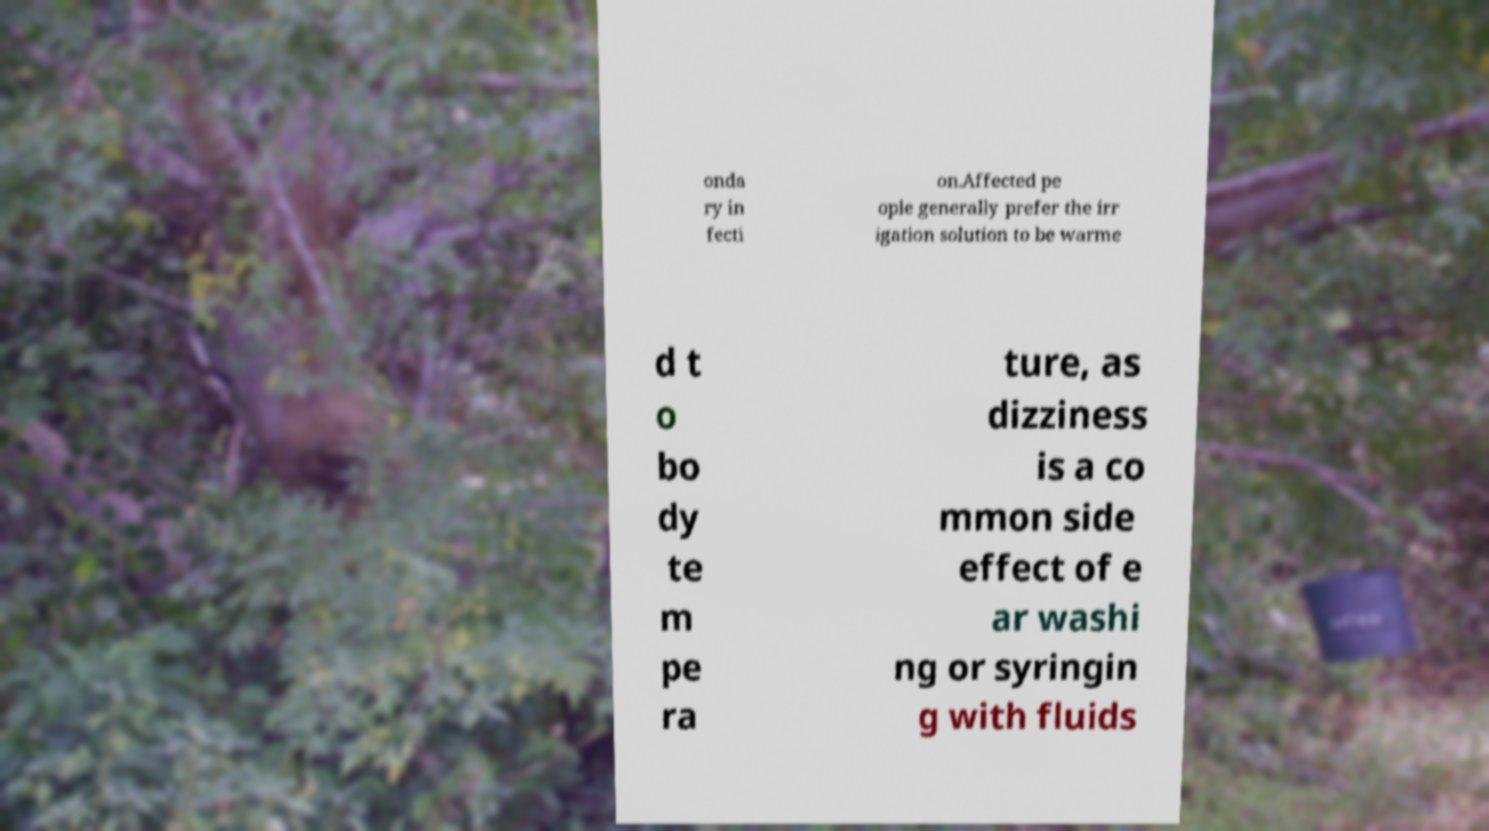What messages or text are displayed in this image? I need them in a readable, typed format. onda ry in fecti on.Affected pe ople generally prefer the irr igation solution to be warme d t o bo dy te m pe ra ture, as dizziness is a co mmon side effect of e ar washi ng or syringin g with fluids 